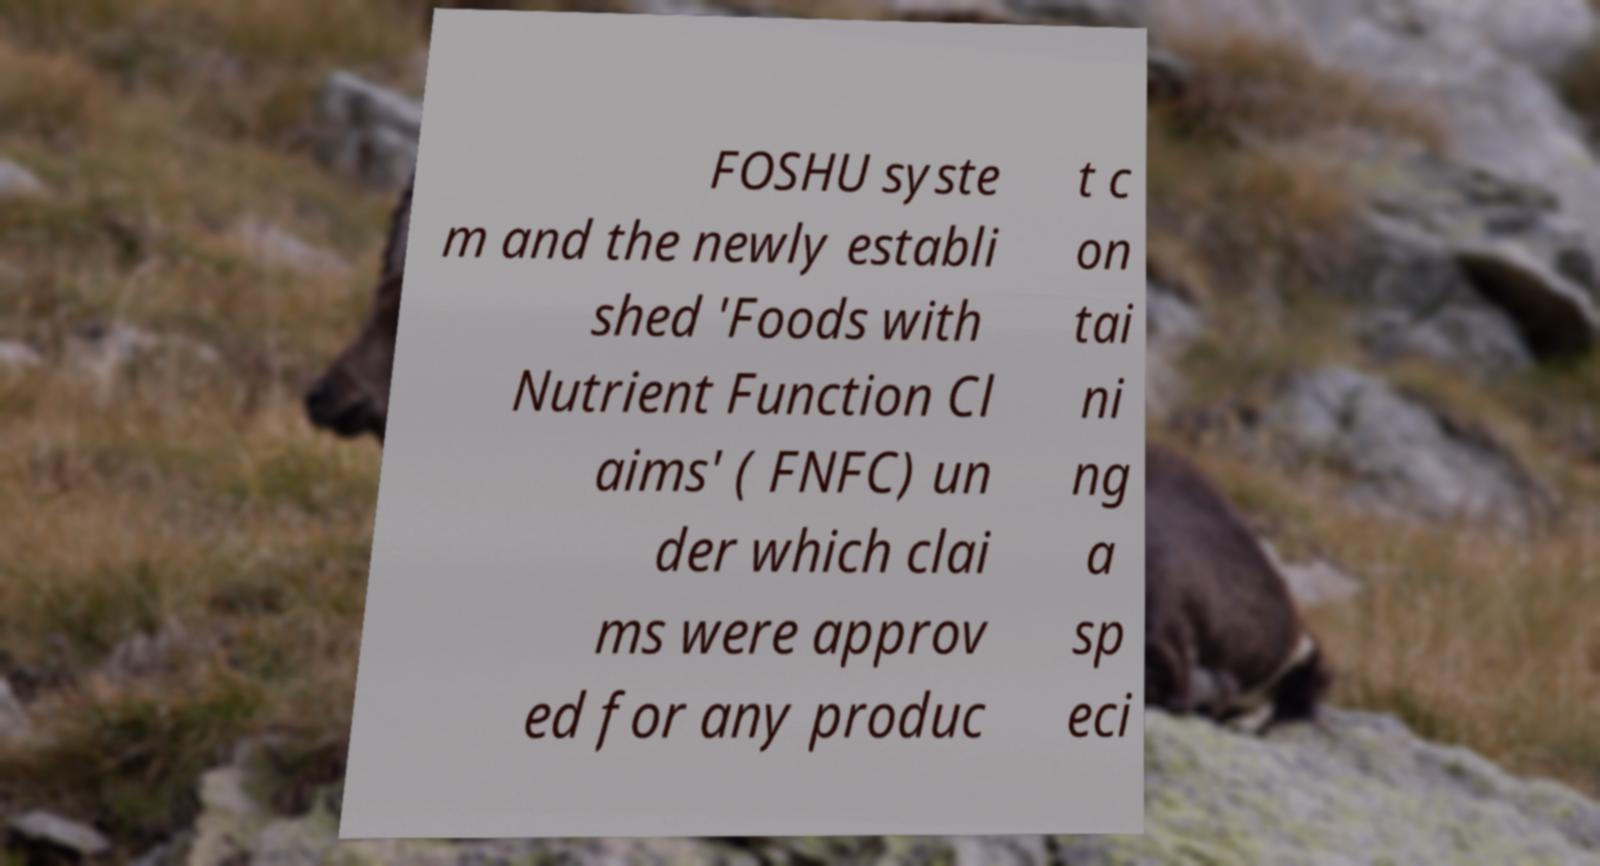Can you accurately transcribe the text from the provided image for me? FOSHU syste m and the newly establi shed 'Foods with Nutrient Function Cl aims' ( FNFC) un der which clai ms were approv ed for any produc t c on tai ni ng a sp eci 